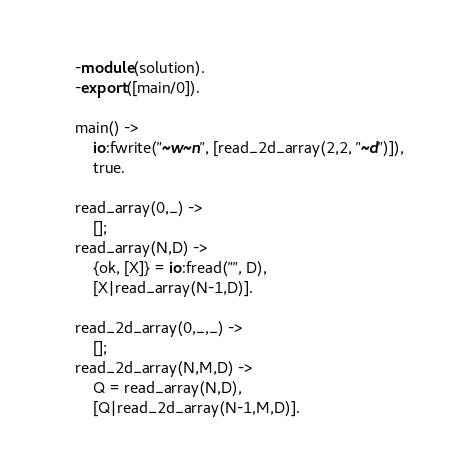<code> <loc_0><loc_0><loc_500><loc_500><_Erlang_>-module(solution).
-export([main/0]).

main() ->
    io:fwrite("~w~n", [read_2d_array(2,2, "~d")]),
    true.

read_array(0,_) ->
    [];
read_array(N,D) ->
    {ok, [X]} = io:fread("", D),
    [X|read_array(N-1,D)].

read_2d_array(0,_,_) ->
    [];
read_2d_array(N,M,D) ->
    Q = read_array(N,D),
    [Q|read_2d_array(N-1,M,D)].
</code> 